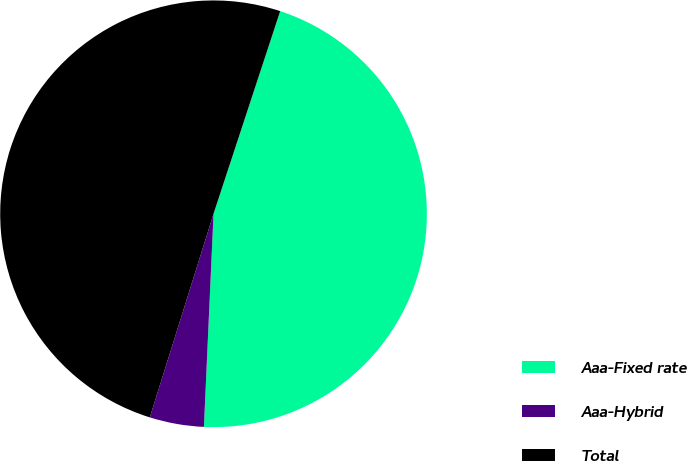Convert chart to OTSL. <chart><loc_0><loc_0><loc_500><loc_500><pie_chart><fcel>Aaa-Fixed rate<fcel>Aaa-Hybrid<fcel>Total<nl><fcel>45.66%<fcel>4.11%<fcel>50.23%<nl></chart> 